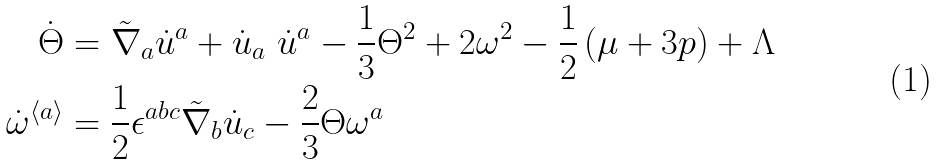<formula> <loc_0><loc_0><loc_500><loc_500>\dot { \Theta } & = \tilde { \nabla } _ { a } \dot { u } ^ { a } + \dot { u } _ { a } \ \dot { u } ^ { a } - \frac { 1 } { 3 } \Theta ^ { 2 } + 2 \omega ^ { 2 } - \frac { 1 } { 2 } \left ( \mu + 3 p \right ) + \Lambda \\ \dot { \omega } ^ { \langle a \rangle } & = \frac { 1 } { 2 } \epsilon ^ { a b c } \tilde { \nabla } _ { b } \dot { u } _ { c } - \frac { 2 } { 3 } \Theta \omega ^ { a }</formula> 